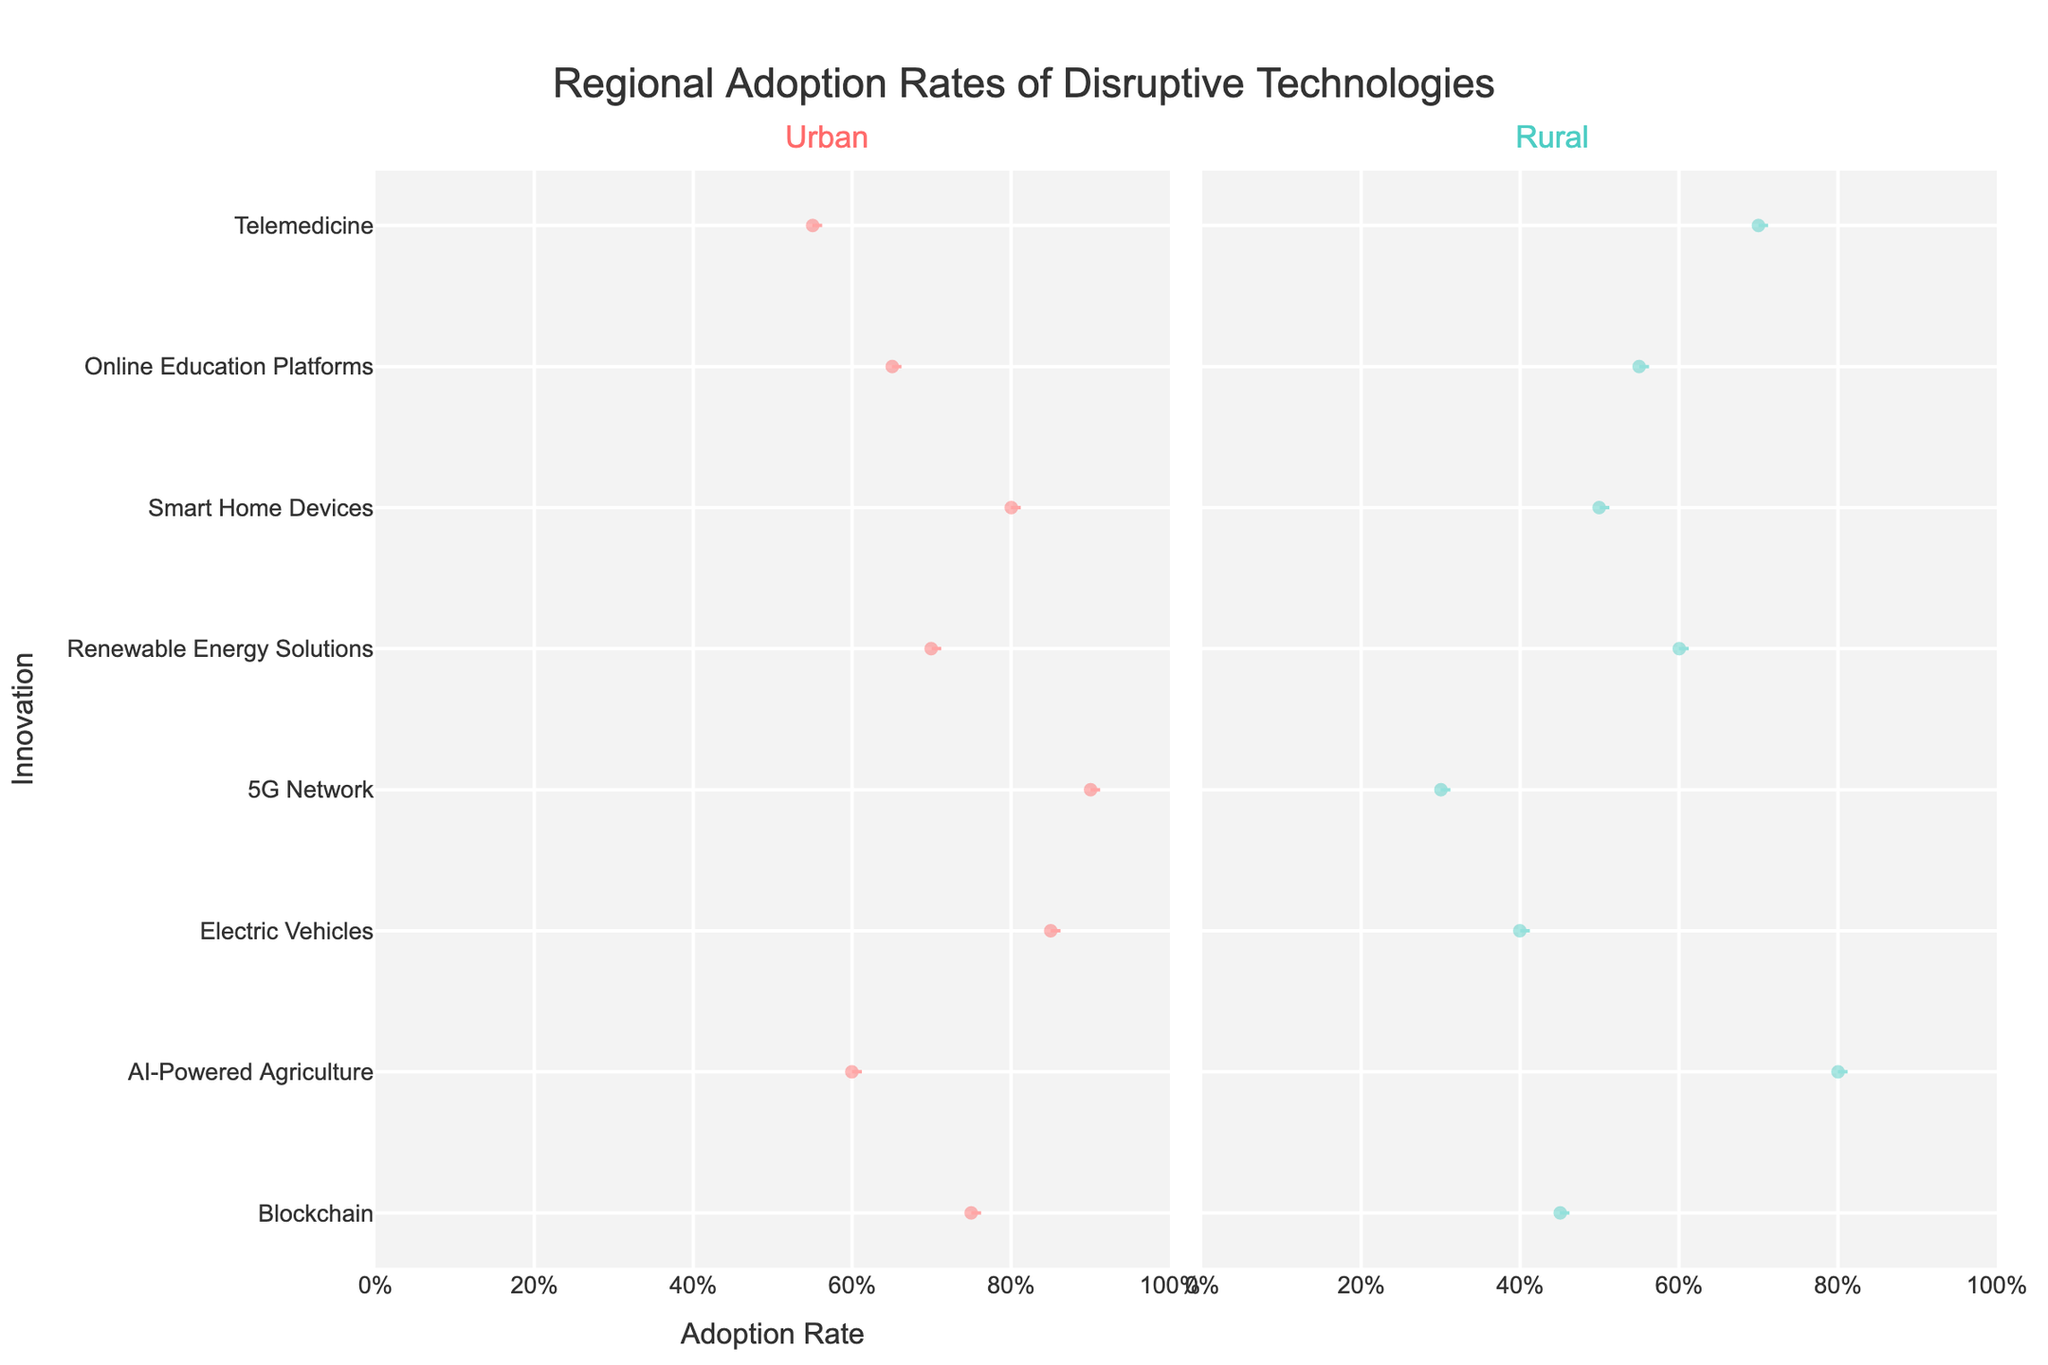What is the title of the chart? The title of the chart is positioned at the top and center of the figure and reads as 'Regional Adoption Rates of Disruptive Technologies'.
Answer: Regional Adoption Rates of Disruptive Technologies Which innovation has the highest adoption rate in rural areas? By examining the positions of the highest points on the rural subplot (right subplot), we can see that AI-Powered Agriculture has the highest adoption rate at 0.80.
Answer: AI-Powered Agriculture Between urban and rural areas, which one has a higher average adoption rate for Blockchain technology? The adoption rates for Blockchain are 0.75 for urban and 0.45 for rural. The average for urban (0.75) is higher than that for rural (0.45).
Answer: Urban What is the range of adoption rates for Electric Vehicles in both areas? The adoption rates for Electric Vehicles in urban areas is 0.85 and in rural areas is 0.40. The range can be calculated by subtracting the lowest adoption rate from the highest.
Answer: 0.45 Which innovations have a higher adoption rate in urban areas compared to rural areas, and by how much? By comparing the adoption rates for each innovation in both areas, we find that Blockchain (0.75 vs. 0.45), Electric Vehicles (0.85 vs. 0.40), 5G Network (0.90 vs. 0.30), Smart Home Devices (0.80 vs. 0.50), and Online Education Platforms (0.65 vs. 0.55) have higher rates in urban areas. Subtracting the adoption rates gives the differences: Blockchain (0.30), Electric Vehicles (0.45), 5G Network (0.60), Smart Home Devices (0.30), Online Education Platforms (0.10).
Answer: Blockchain (0.30), Electric Vehicles (0.45), 5G Network (0.60), Smart Home Devices (0.30), Online Education Platforms (0.10) Which has a lower adoption rate in urban areas, Telemedicine or Renewable Energy Solutions? Looking at the urban area subplot (left subplot) adoption rates, Telemedicine has an adoption rate of 0.55 while Renewable Energy Solutions has an adoption rate of 0.70. Therefore, Telemedicine has a lower adoption rate.
Answer: Telemedicine What is the difference in adoption rates of 5G Network between urban and rural areas? The adoption rates for 5G Network are 0.90 for urban areas and 0.30 for rural areas. The difference is calculated as 0.90 - 0.30.
Answer: 0.60 How many technologies have their adoption rates above 0.6 in urban areas? Filtering the urban subplot for technologies with adoption rates above 0.6, we observe Blockchain (0.75), Electric Vehicles (0.85), 5G Network (0.90), Renewable Energy Solutions (0.70), and Smart Home Devices (0.80).
Answer: 5 Are there any technologies with equal adoption rates in both urban and rural areas? By comparing the adoption rates for all technologies in both areas, we see that no technologies have the same adoption rates.
Answer: No 